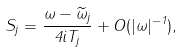Convert formula to latex. <formula><loc_0><loc_0><loc_500><loc_500>S _ { j } = \frac { \omega - \widetilde { \omega } _ { j } } { 4 i T _ { j } } + O ( | \omega | ^ { - 1 } ) ,</formula> 